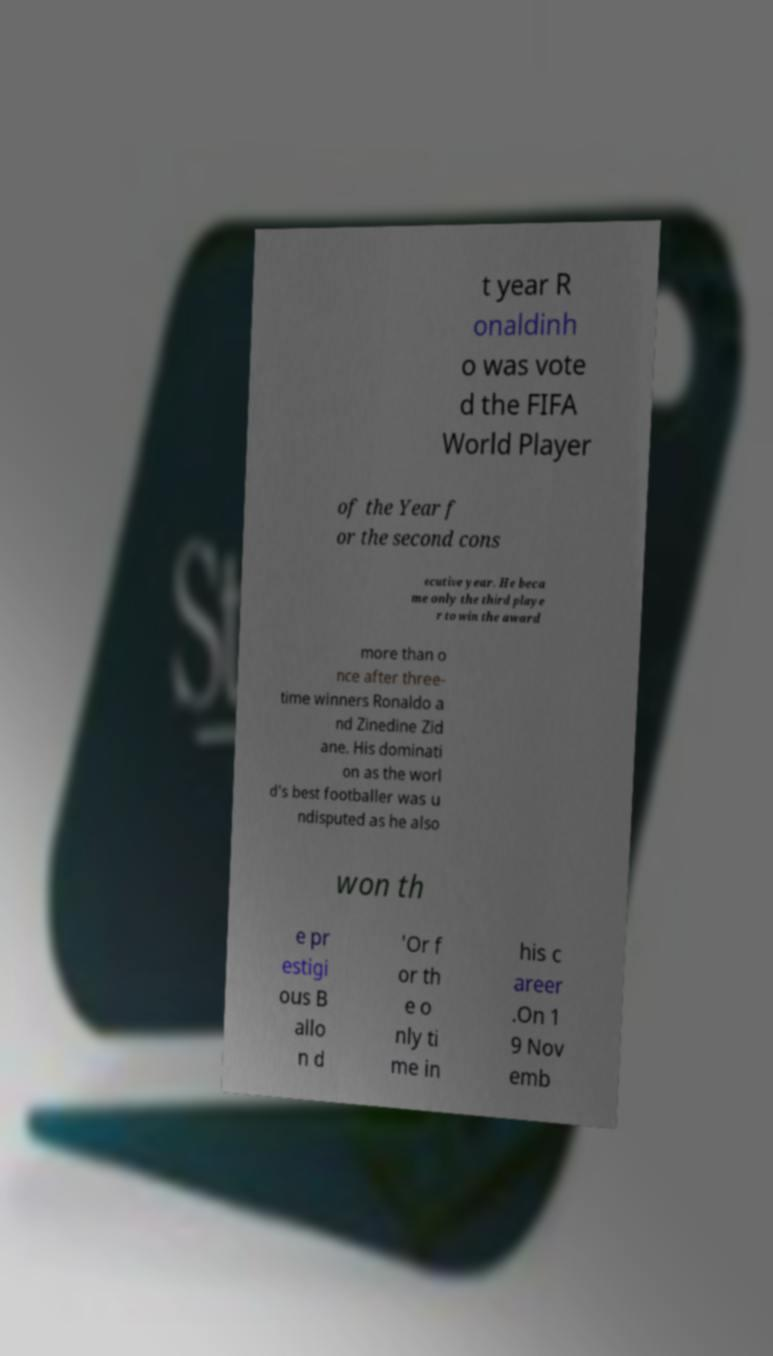Please identify and transcribe the text found in this image. t year R onaldinh o was vote d the FIFA World Player of the Year f or the second cons ecutive year. He beca me only the third playe r to win the award more than o nce after three- time winners Ronaldo a nd Zinedine Zid ane. His dominati on as the worl d's best footballer was u ndisputed as he also won th e pr estigi ous B allo n d 'Or f or th e o nly ti me in his c areer .On 1 9 Nov emb 